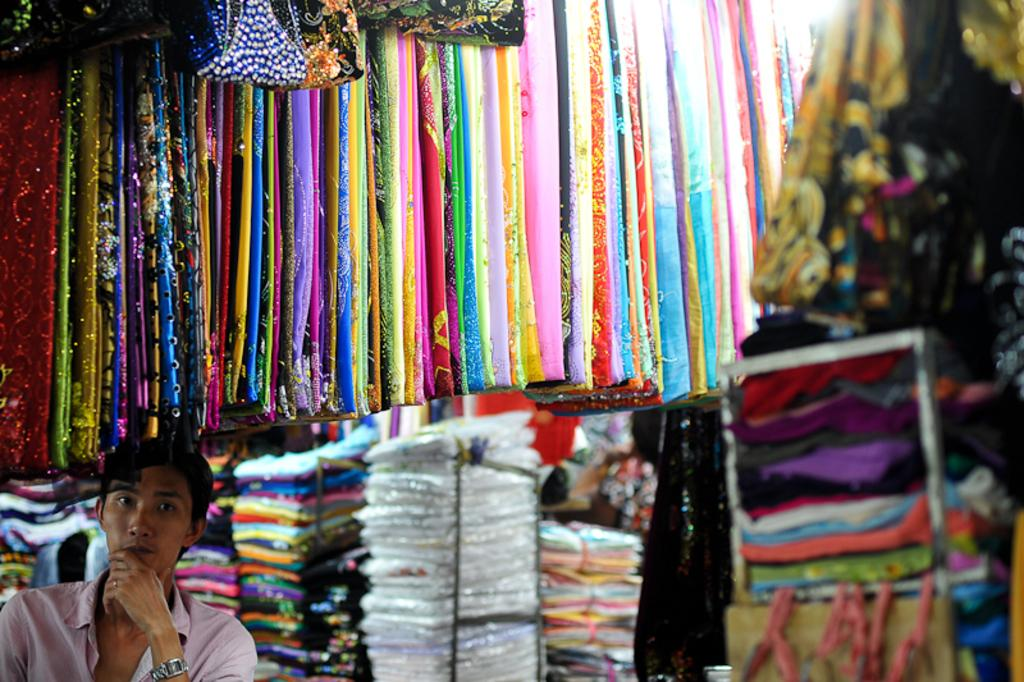What type of clothes can be seen in the image? There are colorful clothes in the image. Who is present in the image? There is a person in the image. What is the person wearing? The person is wearing clothes and a watch. Where is the person located in the image? The person is located in the bottom left of the image. What type of grip does the person have on the experience in the image? There is no mention of grip or experience in the image; it only shows a person wearing colorful clothes and a watch. 